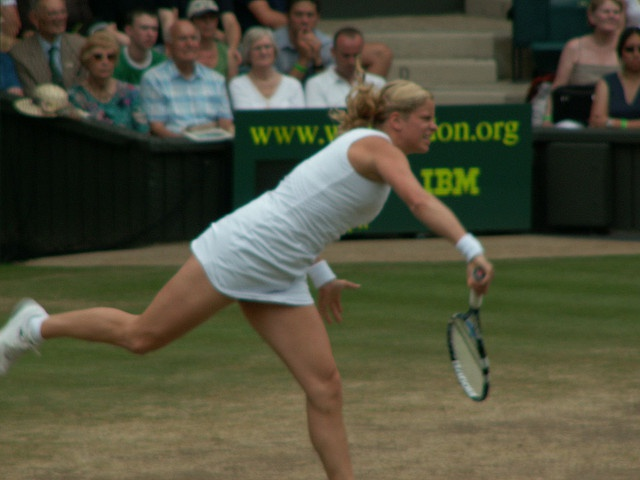Describe the objects in this image and their specific colors. I can see people in teal, maroon, gray, and darkgray tones, people in teal, gray, darkgray, and maroon tones, people in teal, black, gray, and maroon tones, people in teal, black, and gray tones, and people in teal, gray, black, and maroon tones in this image. 